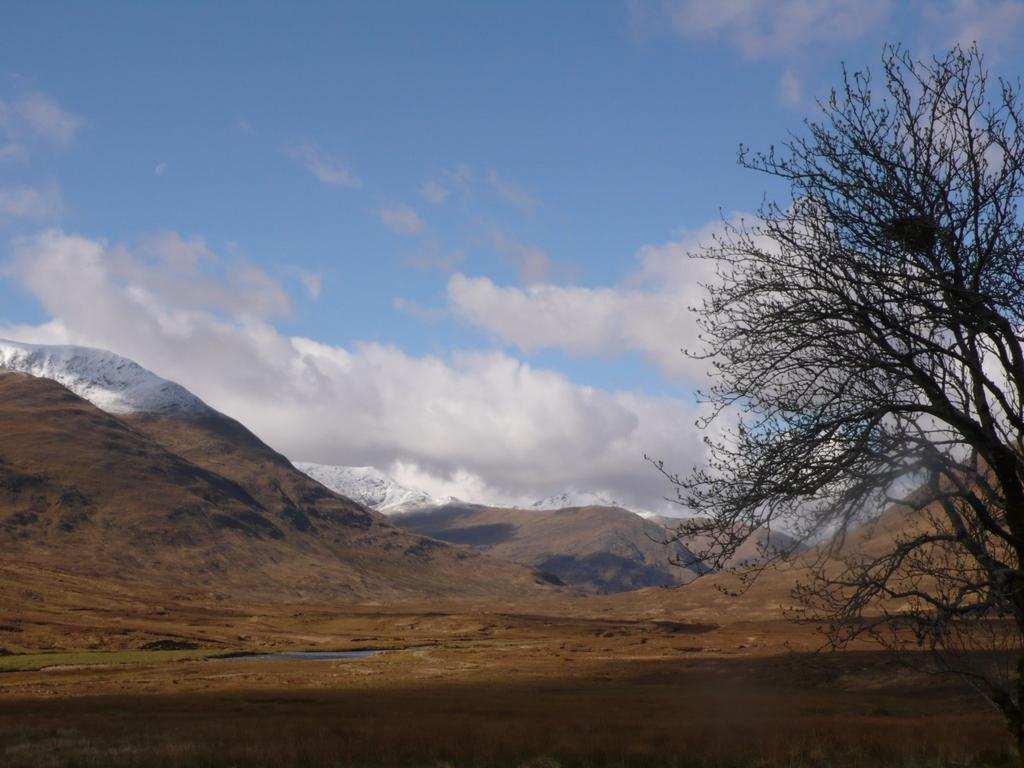What type of landscape is depicted in the image? There is a land in the image. What geographical features can be seen in the background? There are hills visible in the background of the image. What part of the natural environment is visible in the image? The sky is visible in the background of the image. What type of vegetation is on the right side of the image? There is a tree on the right side of the image. What time is it in the image? The image does not provide any information about the time. --- Facts: 1. There is a person in the image. 2. The person is wearing a hat. 3. The person is holding a book. 4. The person is sitting on a chair. 5. There is a table next to the person. Absurd Topics: elephant, piano Conversation: Who or what is the main subject in the image? The main subject in the image is a person. What is the person wearing in the image? The person is wearing a hat in the image. What is the person holding in the image? The person is holding a book in the image. What is the person doing in the image? The person is sitting on a chair in the image. What is next to the person in the image? There is a table next to the person in the image. Reasoning: Let's think step by step in order to produce the conversation. We start by identifying the main subject of the image, which is a person. Then, we describe the person's attire, actions, and the objects around them. We ensure that each question can be answered definitively with the information given. We avoid yes/no questions and ensure that the language is simple and clear. Absurd Question/Answer: What type of elephant can be seen playing the piano in the image? There is no elephant or piano present in the image. 